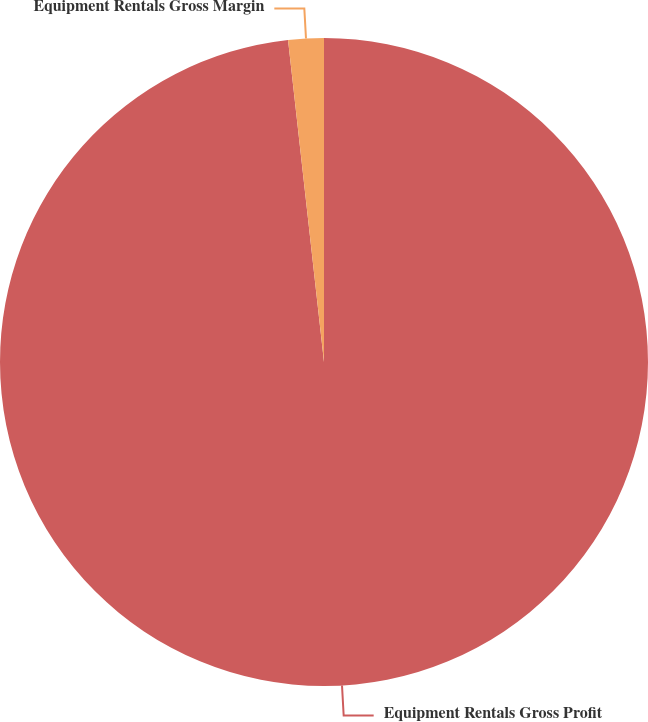<chart> <loc_0><loc_0><loc_500><loc_500><pie_chart><fcel>Equipment Rentals Gross Profit<fcel>Equipment Rentals Gross Margin<nl><fcel>98.23%<fcel>1.77%<nl></chart> 